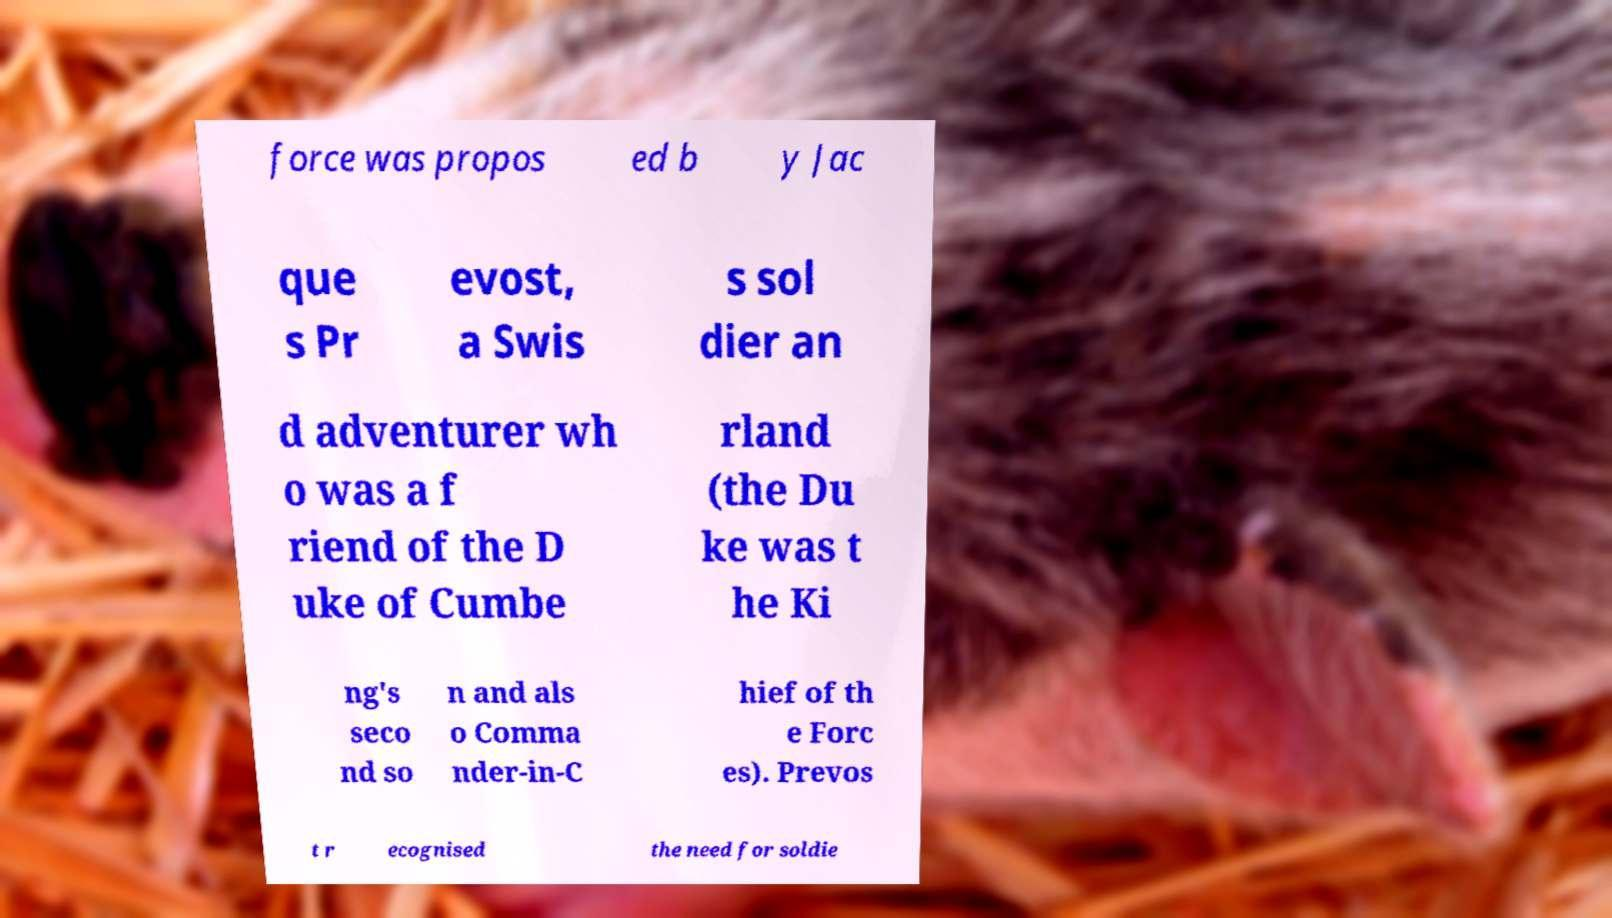Please read and relay the text visible in this image. What does it say? force was propos ed b y Jac que s Pr evost, a Swis s sol dier an d adventurer wh o was a f riend of the D uke of Cumbe rland (the Du ke was t he Ki ng's seco nd so n and als o Comma nder-in-C hief of th e Forc es). Prevos t r ecognised the need for soldie 